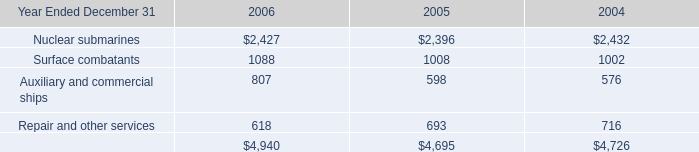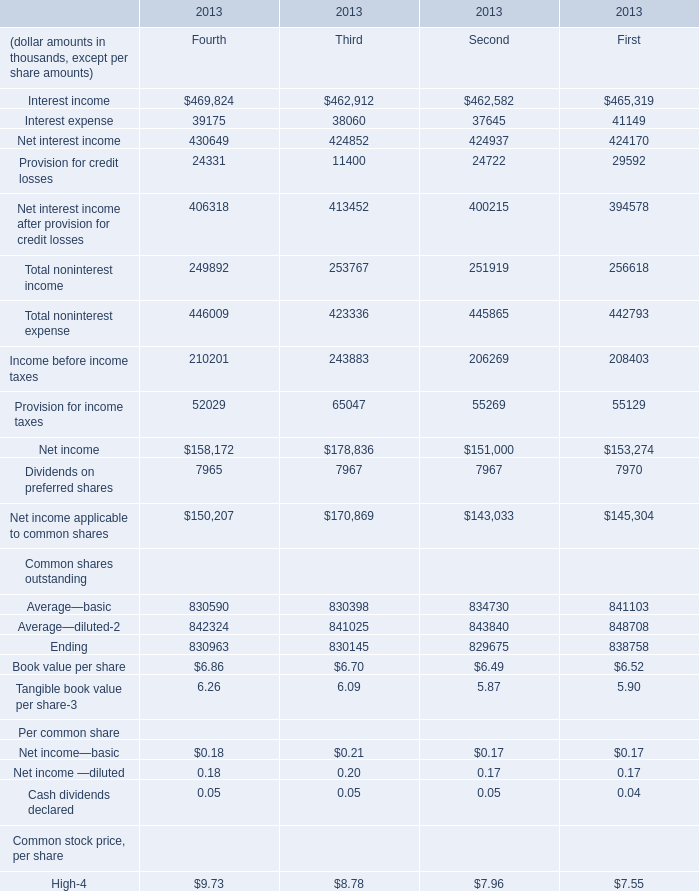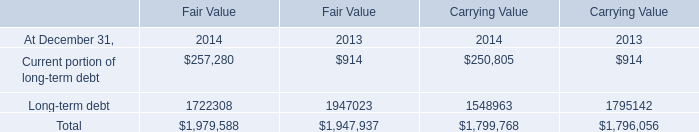What is the total amount of Nuclear submarines of 2006, Net income applicable to common shares of 2013 Second, and Net interest income Revenue—FTE of 2013 Second ? 
Computations: ((2427.0 + 143033.0) + 431524.0)
Answer: 576984.0. 